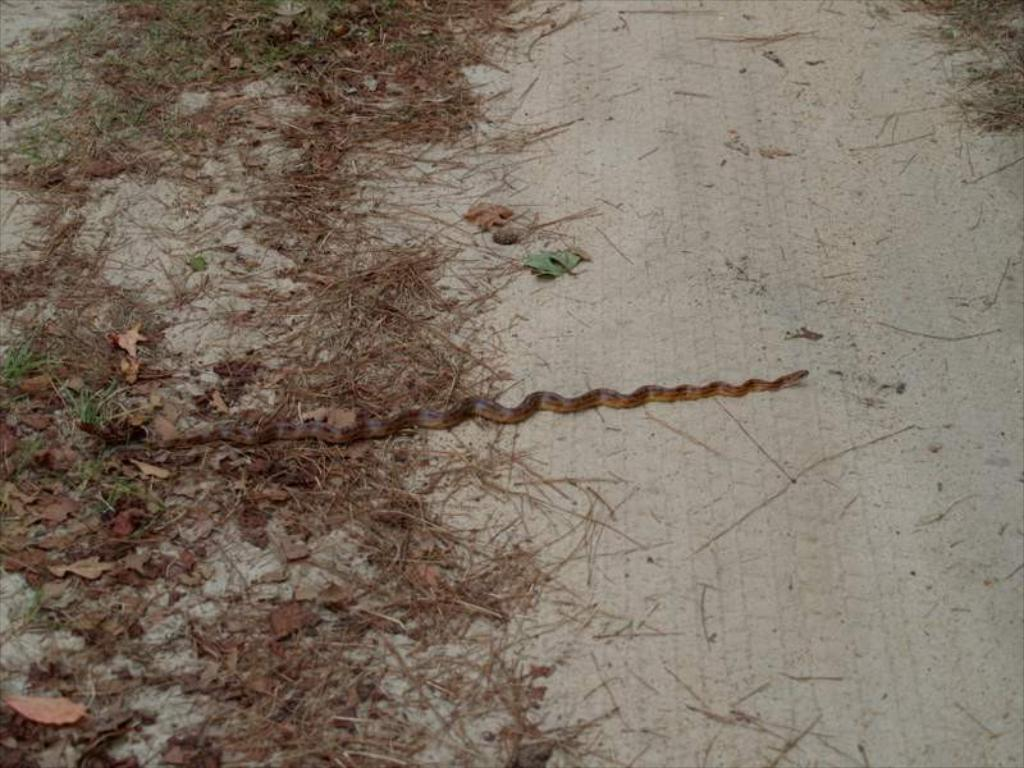What type of animal is in the image? There is a snake in the image. What else can be seen on the ground in the image? Dried leaves are present in the image. Where are the snake and dried leaves located? The snake and dried leaves are on the ground. How does the bat contribute to the growth of the snake in the image? There is no bat present in the image, so it cannot contribute to the snake's growth. 